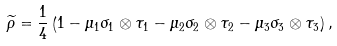Convert formula to latex. <formula><loc_0><loc_0><loc_500><loc_500>\widetilde { \rho } = \frac { 1 } { 4 } \left ( 1 - \mu _ { 1 } \sigma _ { 1 } \otimes \tau _ { 1 } - \mu _ { 2 } \sigma _ { 2 } \otimes \tau _ { 2 } - \mu _ { 3 } \sigma _ { 3 } \otimes \tau _ { 3 } \right ) ,</formula> 